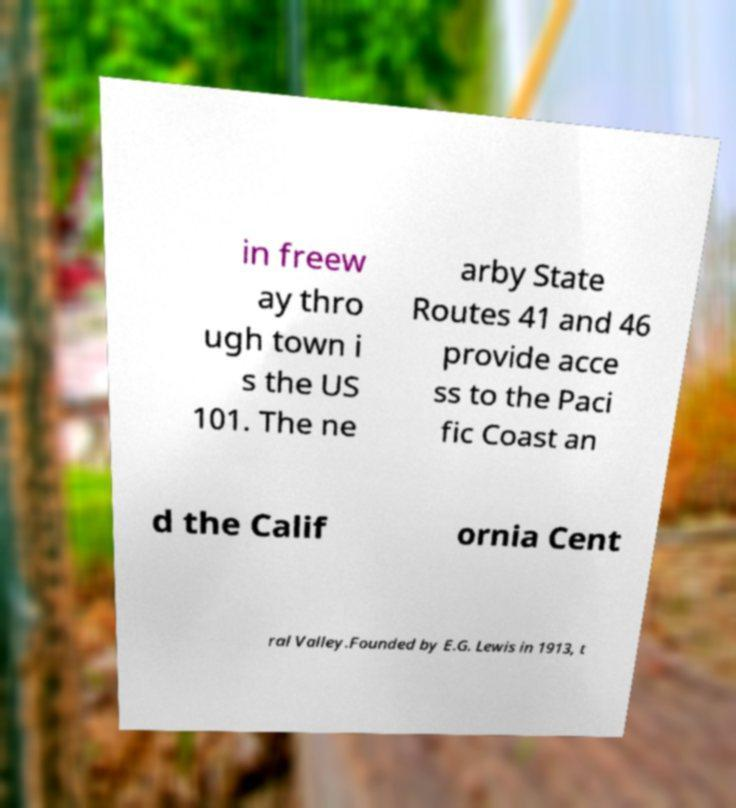Can you read and provide the text displayed in the image?This photo seems to have some interesting text. Can you extract and type it out for me? in freew ay thro ugh town i s the US 101. The ne arby State Routes 41 and 46 provide acce ss to the Paci fic Coast an d the Calif ornia Cent ral Valley.Founded by E.G. Lewis in 1913, t 